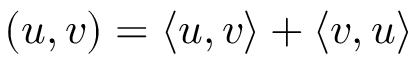Convert formula to latex. <formula><loc_0><loc_0><loc_500><loc_500>( u , v ) = \langle u , v \rangle + \langle v , u \rangle</formula> 